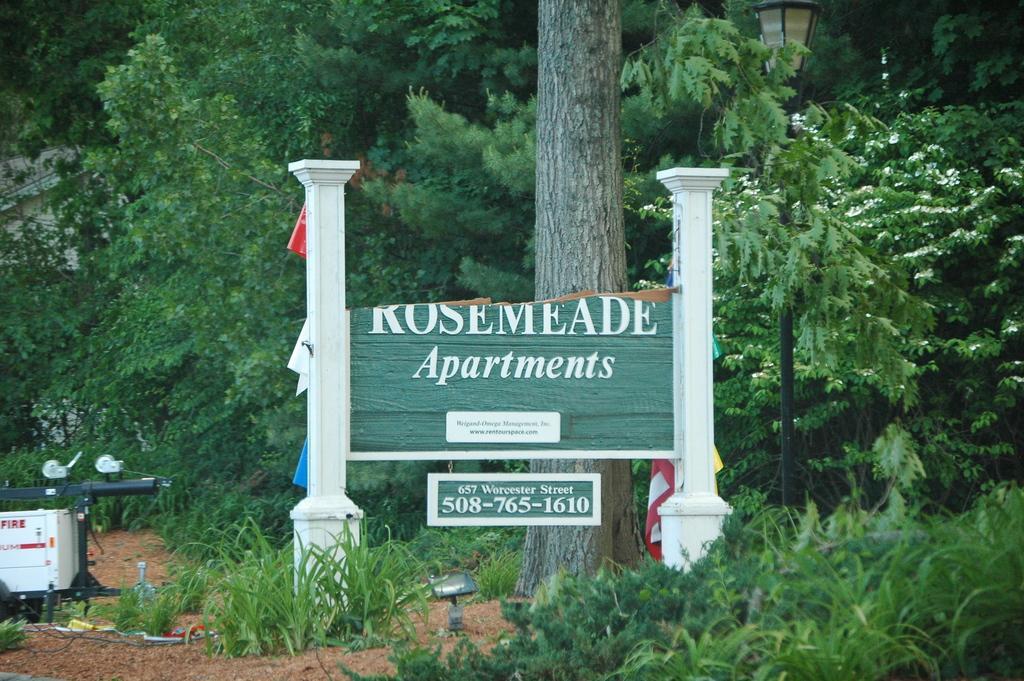Could you give a brief overview of what you see in this image? In this image there is a board, on that board there is some text, in the background there are trees and a light pole. 